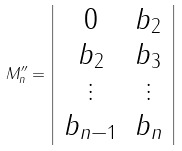<formula> <loc_0><loc_0><loc_500><loc_500>M ^ { \prime \prime } _ { n } = \left | \begin{array} { c c } 0 & b _ { 2 } \\ b _ { 2 } & b _ { 3 } \\ \vdots & \vdots \\ b _ { n - 1 } & b _ { n } \end{array} \right |</formula> 